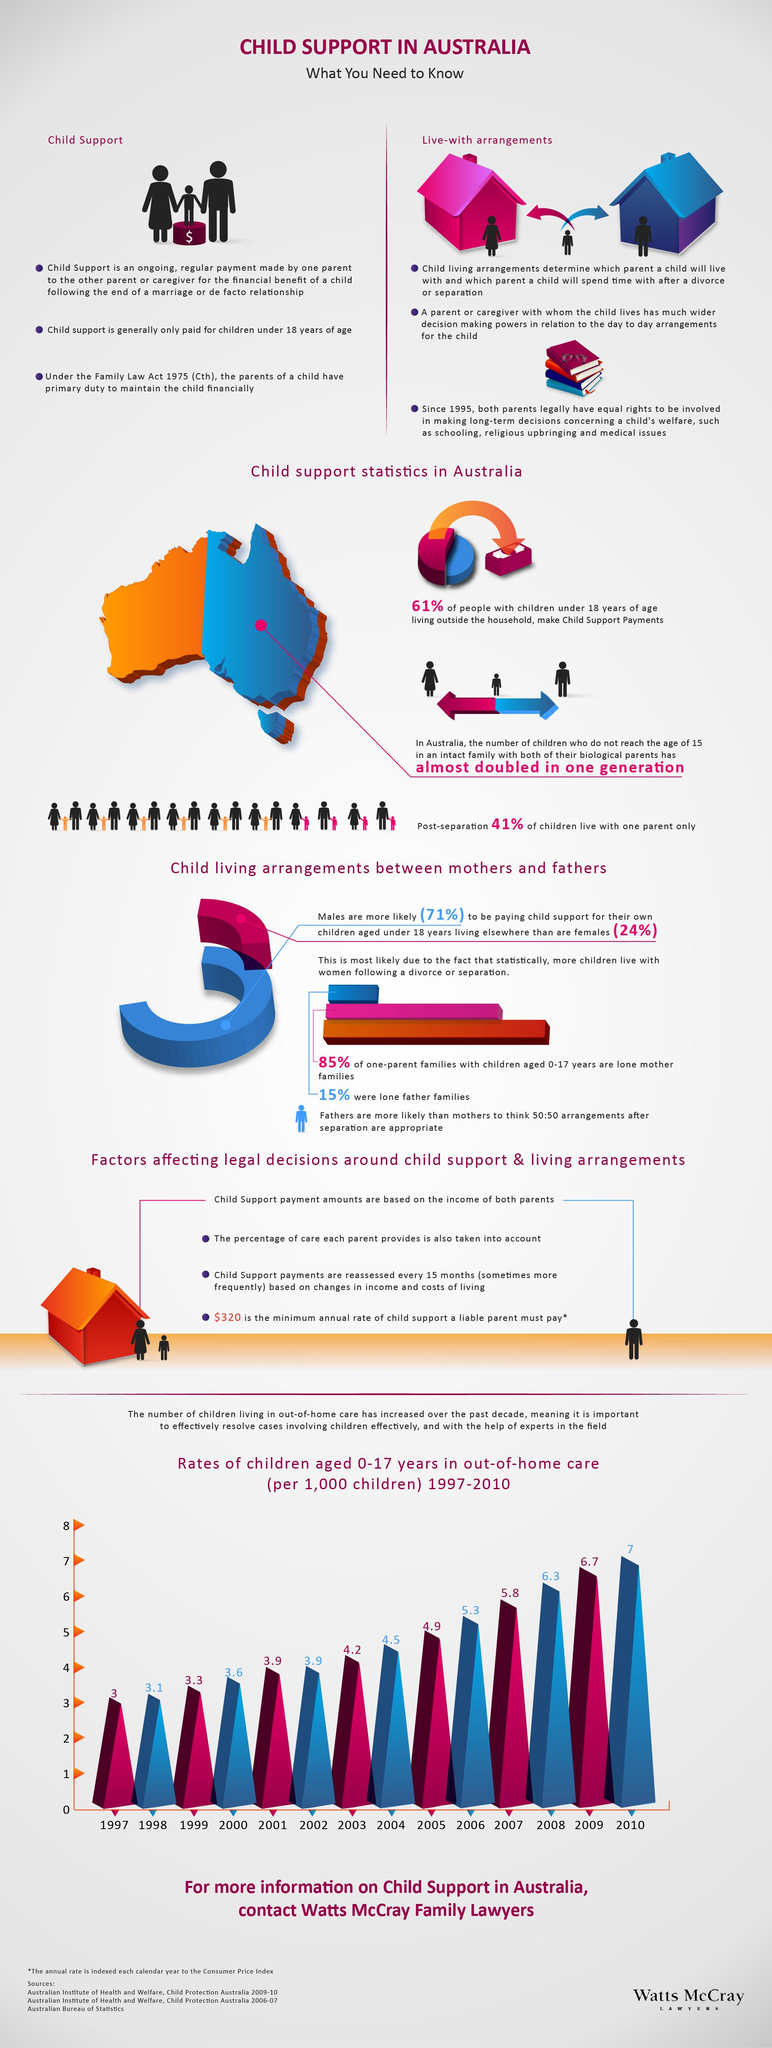Highlight a few significant elements in this photo. According to the information provided, approximately 39% of people living outside the household fail to make child support payments. The rate of children in out-of-home care increased by 4% from 1997 to 2010. 